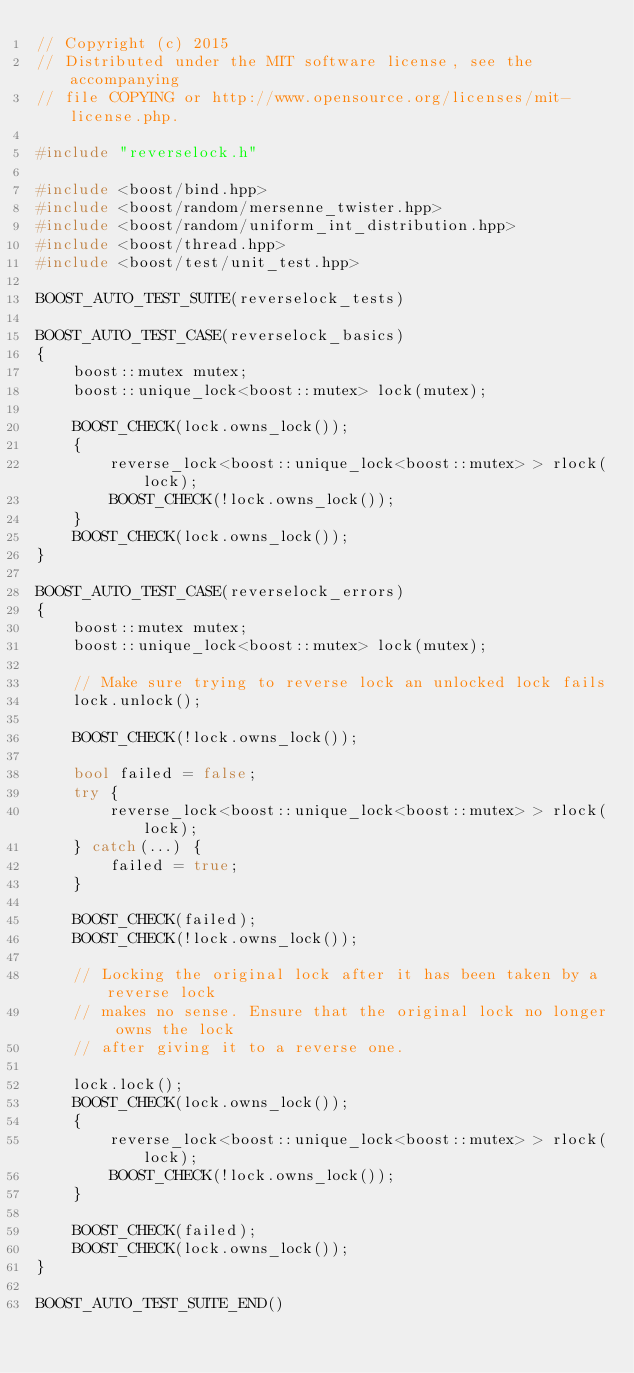<code> <loc_0><loc_0><loc_500><loc_500><_C++_>// Copyright (c) 2015  
// Distributed under the MIT software license, see the accompanying
// file COPYING or http://www.opensource.org/licenses/mit-license.php.

#include "reverselock.h"

#include <boost/bind.hpp>
#include <boost/random/mersenne_twister.hpp>
#include <boost/random/uniform_int_distribution.hpp>
#include <boost/thread.hpp>
#include <boost/test/unit_test.hpp>

BOOST_AUTO_TEST_SUITE(reverselock_tests)

BOOST_AUTO_TEST_CASE(reverselock_basics)
{
    boost::mutex mutex;
    boost::unique_lock<boost::mutex> lock(mutex);

    BOOST_CHECK(lock.owns_lock());
    {
        reverse_lock<boost::unique_lock<boost::mutex> > rlock(lock);
        BOOST_CHECK(!lock.owns_lock());
    }
    BOOST_CHECK(lock.owns_lock());
}

BOOST_AUTO_TEST_CASE(reverselock_errors)
{
    boost::mutex mutex;
    boost::unique_lock<boost::mutex> lock(mutex);

    // Make sure trying to reverse lock an unlocked lock fails
    lock.unlock();

    BOOST_CHECK(!lock.owns_lock());

    bool failed = false;
    try {
        reverse_lock<boost::unique_lock<boost::mutex> > rlock(lock);
    } catch(...) {
        failed = true;
    }

    BOOST_CHECK(failed);
    BOOST_CHECK(!lock.owns_lock());

    // Locking the original lock after it has been taken by a reverse lock
    // makes no sense. Ensure that the original lock no longer owns the lock
    // after giving it to a reverse one.

    lock.lock();
    BOOST_CHECK(lock.owns_lock());
    {
        reverse_lock<boost::unique_lock<boost::mutex> > rlock(lock);
        BOOST_CHECK(!lock.owns_lock());
    }

    BOOST_CHECK(failed);
    BOOST_CHECK(lock.owns_lock());
}

BOOST_AUTO_TEST_SUITE_END()
</code> 